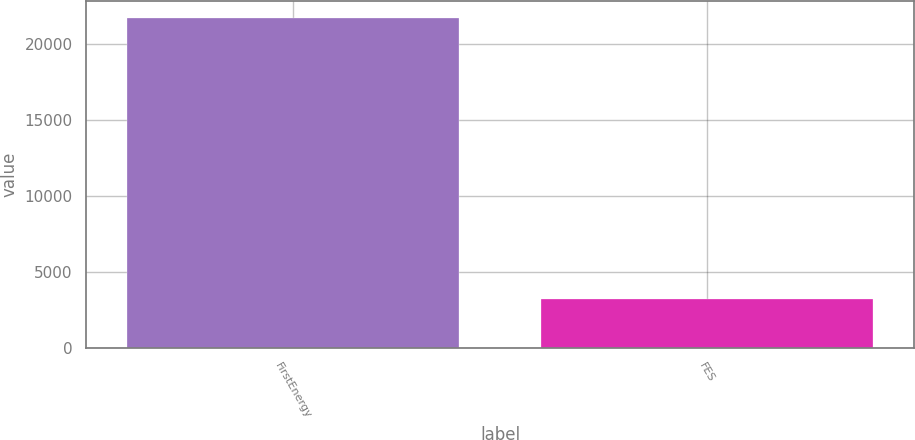Convert chart. <chart><loc_0><loc_0><loc_500><loc_500><bar_chart><fcel>FirstEnergy<fcel>FES<nl><fcel>21733<fcel>3241<nl></chart> 